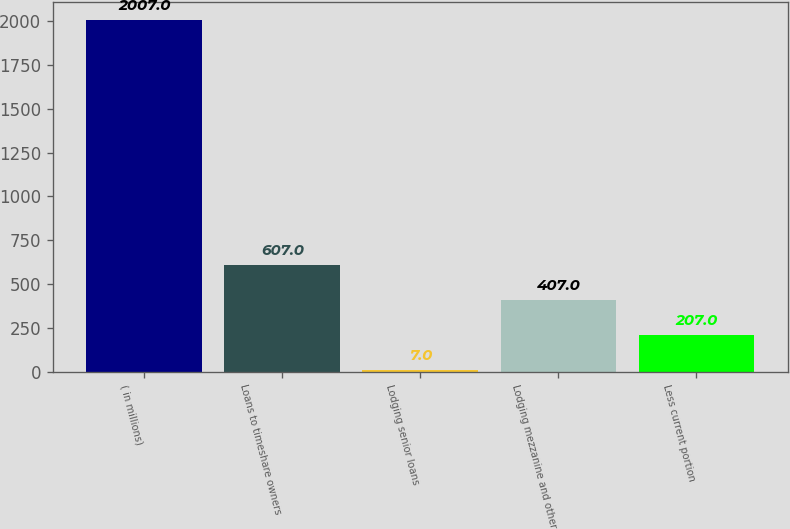<chart> <loc_0><loc_0><loc_500><loc_500><bar_chart><fcel>( in millions)<fcel>Loans to timeshare owners<fcel>Lodging senior loans<fcel>Lodging mezzanine and other<fcel>Less current portion<nl><fcel>2007<fcel>607<fcel>7<fcel>407<fcel>207<nl></chart> 